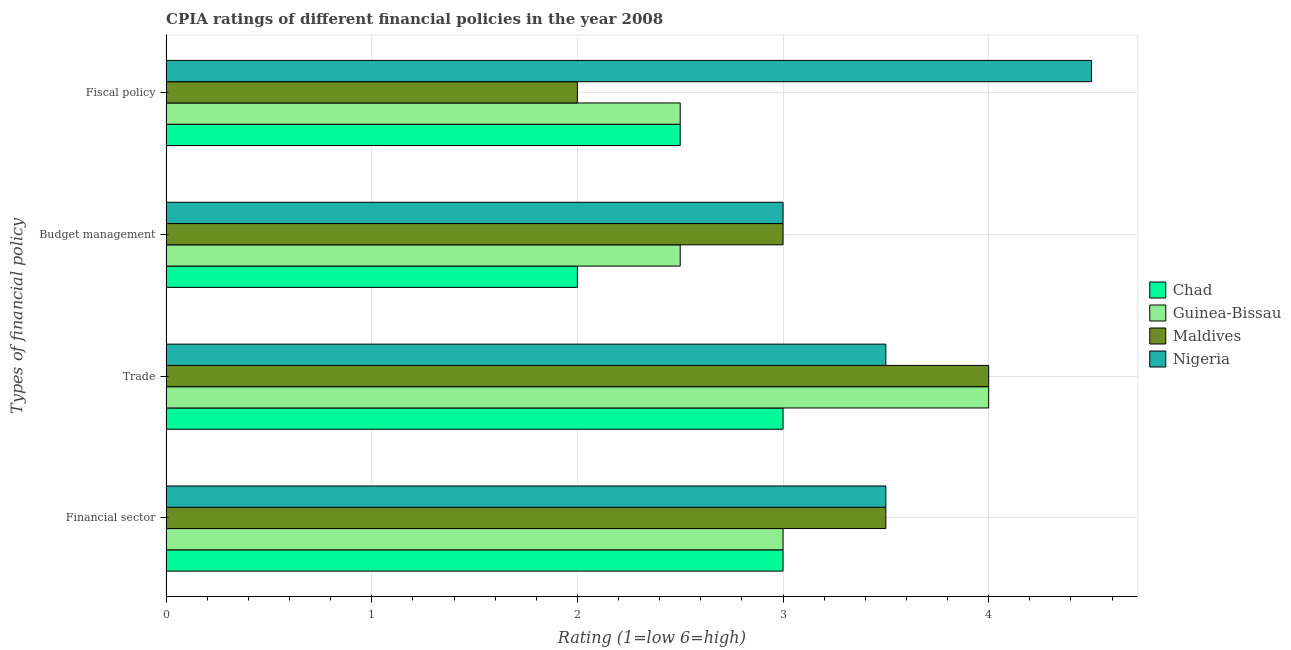How many different coloured bars are there?
Ensure brevity in your answer.  4. Are the number of bars on each tick of the Y-axis equal?
Offer a terse response. Yes. How many bars are there on the 3rd tick from the top?
Give a very brief answer. 4. How many bars are there on the 2nd tick from the bottom?
Your answer should be compact. 4. What is the label of the 3rd group of bars from the top?
Make the answer very short. Trade. Across all countries, what is the maximum cpia rating of budget management?
Offer a terse response. 3. Across all countries, what is the minimum cpia rating of trade?
Provide a short and direct response. 3. In which country was the cpia rating of budget management maximum?
Keep it short and to the point. Maldives. In which country was the cpia rating of fiscal policy minimum?
Give a very brief answer. Maldives. What is the total cpia rating of financial sector in the graph?
Your answer should be very brief. 13. What is the difference between the cpia rating of trade in Maldives and that in Nigeria?
Ensure brevity in your answer.  0.5. What is the average cpia rating of financial sector per country?
Ensure brevity in your answer.  3.25. What is the difference between the cpia rating of budget management and cpia rating of financial sector in Guinea-Bissau?
Give a very brief answer. -0.5. What is the ratio of the cpia rating of fiscal policy in Guinea-Bissau to that in Nigeria?
Your answer should be compact. 0.56. Is the difference between the cpia rating of fiscal policy in Guinea-Bissau and Chad greater than the difference between the cpia rating of trade in Guinea-Bissau and Chad?
Make the answer very short. No. What is the difference between the highest and the second highest cpia rating of budget management?
Ensure brevity in your answer.  0. Is it the case that in every country, the sum of the cpia rating of fiscal policy and cpia rating of budget management is greater than the sum of cpia rating of trade and cpia rating of financial sector?
Your response must be concise. No. What does the 2nd bar from the top in Trade represents?
Your response must be concise. Maldives. What does the 4th bar from the bottom in Financial sector represents?
Offer a very short reply. Nigeria. Is it the case that in every country, the sum of the cpia rating of financial sector and cpia rating of trade is greater than the cpia rating of budget management?
Ensure brevity in your answer.  Yes. How many countries are there in the graph?
Your response must be concise. 4. Does the graph contain any zero values?
Offer a very short reply. No. Where does the legend appear in the graph?
Offer a terse response. Center right. How are the legend labels stacked?
Your response must be concise. Vertical. What is the title of the graph?
Your answer should be compact. CPIA ratings of different financial policies in the year 2008. Does "Somalia" appear as one of the legend labels in the graph?
Provide a short and direct response. No. What is the label or title of the Y-axis?
Make the answer very short. Types of financial policy. What is the Rating (1=low 6=high) of Maldives in Financial sector?
Your answer should be compact. 3.5. What is the Rating (1=low 6=high) of Chad in Trade?
Your response must be concise. 3. What is the Rating (1=low 6=high) in Guinea-Bissau in Trade?
Make the answer very short. 4. What is the Rating (1=low 6=high) in Nigeria in Trade?
Your answer should be compact. 3.5. What is the Rating (1=low 6=high) in Chad in Budget management?
Provide a succinct answer. 2. What is the Rating (1=low 6=high) of Guinea-Bissau in Budget management?
Provide a succinct answer. 2.5. What is the Rating (1=low 6=high) in Nigeria in Budget management?
Offer a very short reply. 3. What is the Rating (1=low 6=high) of Chad in Fiscal policy?
Offer a terse response. 2.5. What is the Rating (1=low 6=high) of Guinea-Bissau in Fiscal policy?
Your answer should be very brief. 2.5. Across all Types of financial policy, what is the maximum Rating (1=low 6=high) in Nigeria?
Your response must be concise. 4.5. Across all Types of financial policy, what is the minimum Rating (1=low 6=high) of Maldives?
Your answer should be compact. 2. Across all Types of financial policy, what is the minimum Rating (1=low 6=high) in Nigeria?
Your response must be concise. 3. What is the total Rating (1=low 6=high) of Chad in the graph?
Your response must be concise. 10.5. What is the total Rating (1=low 6=high) of Nigeria in the graph?
Provide a short and direct response. 14.5. What is the difference between the Rating (1=low 6=high) of Chad in Financial sector and that in Trade?
Your answer should be very brief. 0. What is the difference between the Rating (1=low 6=high) of Maldives in Financial sector and that in Trade?
Your response must be concise. -0.5. What is the difference between the Rating (1=low 6=high) in Chad in Financial sector and that in Budget management?
Offer a terse response. 1. What is the difference between the Rating (1=low 6=high) of Guinea-Bissau in Financial sector and that in Budget management?
Your answer should be compact. 0.5. What is the difference between the Rating (1=low 6=high) in Nigeria in Financial sector and that in Budget management?
Your answer should be compact. 0.5. What is the difference between the Rating (1=low 6=high) in Guinea-Bissau in Financial sector and that in Fiscal policy?
Provide a succinct answer. 0.5. What is the difference between the Rating (1=low 6=high) in Maldives in Financial sector and that in Fiscal policy?
Your response must be concise. 1.5. What is the difference between the Rating (1=low 6=high) in Nigeria in Financial sector and that in Fiscal policy?
Make the answer very short. -1. What is the difference between the Rating (1=low 6=high) in Maldives in Trade and that in Budget management?
Keep it short and to the point. 1. What is the difference between the Rating (1=low 6=high) of Guinea-Bissau in Trade and that in Fiscal policy?
Make the answer very short. 1.5. What is the difference between the Rating (1=low 6=high) in Nigeria in Budget management and that in Fiscal policy?
Provide a short and direct response. -1.5. What is the difference between the Rating (1=low 6=high) of Chad in Financial sector and the Rating (1=low 6=high) of Guinea-Bissau in Trade?
Give a very brief answer. -1. What is the difference between the Rating (1=low 6=high) in Maldives in Financial sector and the Rating (1=low 6=high) in Nigeria in Trade?
Provide a succinct answer. 0. What is the difference between the Rating (1=low 6=high) in Chad in Financial sector and the Rating (1=low 6=high) in Maldives in Budget management?
Your answer should be very brief. 0. What is the difference between the Rating (1=low 6=high) in Guinea-Bissau in Financial sector and the Rating (1=low 6=high) in Maldives in Budget management?
Provide a succinct answer. 0. What is the difference between the Rating (1=low 6=high) in Chad in Financial sector and the Rating (1=low 6=high) in Guinea-Bissau in Fiscal policy?
Offer a terse response. 0.5. What is the difference between the Rating (1=low 6=high) of Chad in Financial sector and the Rating (1=low 6=high) of Maldives in Fiscal policy?
Offer a terse response. 1. What is the difference between the Rating (1=low 6=high) of Chad in Financial sector and the Rating (1=low 6=high) of Nigeria in Fiscal policy?
Provide a short and direct response. -1.5. What is the difference between the Rating (1=low 6=high) in Guinea-Bissau in Financial sector and the Rating (1=low 6=high) in Maldives in Fiscal policy?
Provide a succinct answer. 1. What is the difference between the Rating (1=low 6=high) of Maldives in Financial sector and the Rating (1=low 6=high) of Nigeria in Fiscal policy?
Give a very brief answer. -1. What is the difference between the Rating (1=low 6=high) in Chad in Trade and the Rating (1=low 6=high) in Guinea-Bissau in Budget management?
Offer a very short reply. 0.5. What is the difference between the Rating (1=low 6=high) in Chad in Trade and the Rating (1=low 6=high) in Nigeria in Budget management?
Provide a succinct answer. 0. What is the difference between the Rating (1=low 6=high) of Maldives in Trade and the Rating (1=low 6=high) of Nigeria in Budget management?
Give a very brief answer. 1. What is the difference between the Rating (1=low 6=high) in Chad in Trade and the Rating (1=low 6=high) in Guinea-Bissau in Fiscal policy?
Your response must be concise. 0.5. What is the difference between the Rating (1=low 6=high) of Chad in Trade and the Rating (1=low 6=high) of Maldives in Fiscal policy?
Provide a succinct answer. 1. What is the difference between the Rating (1=low 6=high) in Chad in Trade and the Rating (1=low 6=high) in Nigeria in Fiscal policy?
Provide a short and direct response. -1.5. What is the difference between the Rating (1=low 6=high) of Guinea-Bissau in Trade and the Rating (1=low 6=high) of Maldives in Fiscal policy?
Give a very brief answer. 2. What is the difference between the Rating (1=low 6=high) of Chad in Budget management and the Rating (1=low 6=high) of Guinea-Bissau in Fiscal policy?
Offer a very short reply. -0.5. What is the difference between the Rating (1=low 6=high) in Chad in Budget management and the Rating (1=low 6=high) in Nigeria in Fiscal policy?
Give a very brief answer. -2.5. What is the difference between the Rating (1=low 6=high) in Guinea-Bissau in Budget management and the Rating (1=low 6=high) in Maldives in Fiscal policy?
Give a very brief answer. 0.5. What is the difference between the Rating (1=low 6=high) in Guinea-Bissau in Budget management and the Rating (1=low 6=high) in Nigeria in Fiscal policy?
Give a very brief answer. -2. What is the average Rating (1=low 6=high) in Chad per Types of financial policy?
Provide a short and direct response. 2.62. What is the average Rating (1=low 6=high) of Guinea-Bissau per Types of financial policy?
Your answer should be very brief. 3. What is the average Rating (1=low 6=high) of Maldives per Types of financial policy?
Offer a terse response. 3.12. What is the average Rating (1=low 6=high) of Nigeria per Types of financial policy?
Offer a very short reply. 3.62. What is the difference between the Rating (1=low 6=high) of Chad and Rating (1=low 6=high) of Guinea-Bissau in Financial sector?
Your answer should be very brief. 0. What is the difference between the Rating (1=low 6=high) in Chad and Rating (1=low 6=high) in Nigeria in Financial sector?
Ensure brevity in your answer.  -0.5. What is the difference between the Rating (1=low 6=high) in Guinea-Bissau and Rating (1=low 6=high) in Nigeria in Financial sector?
Provide a short and direct response. -0.5. What is the difference between the Rating (1=low 6=high) in Chad and Rating (1=low 6=high) in Guinea-Bissau in Trade?
Give a very brief answer. -1. What is the difference between the Rating (1=low 6=high) of Guinea-Bissau and Rating (1=low 6=high) of Maldives in Trade?
Give a very brief answer. 0. What is the difference between the Rating (1=low 6=high) of Guinea-Bissau and Rating (1=low 6=high) of Nigeria in Trade?
Give a very brief answer. 0.5. What is the difference between the Rating (1=low 6=high) in Maldives and Rating (1=low 6=high) in Nigeria in Trade?
Your answer should be very brief. 0.5. What is the difference between the Rating (1=low 6=high) in Chad and Rating (1=low 6=high) in Maldives in Budget management?
Your answer should be compact. -1. What is the difference between the Rating (1=low 6=high) of Guinea-Bissau and Rating (1=low 6=high) of Maldives in Budget management?
Keep it short and to the point. -0.5. What is the difference between the Rating (1=low 6=high) of Guinea-Bissau and Rating (1=low 6=high) of Nigeria in Budget management?
Provide a succinct answer. -0.5. What is the difference between the Rating (1=low 6=high) in Maldives and Rating (1=low 6=high) in Nigeria in Budget management?
Your response must be concise. 0. What is the difference between the Rating (1=low 6=high) of Chad and Rating (1=low 6=high) of Maldives in Fiscal policy?
Keep it short and to the point. 0.5. What is the difference between the Rating (1=low 6=high) in Guinea-Bissau and Rating (1=low 6=high) in Maldives in Fiscal policy?
Offer a very short reply. 0.5. What is the difference between the Rating (1=low 6=high) of Guinea-Bissau and Rating (1=low 6=high) of Nigeria in Fiscal policy?
Provide a short and direct response. -2. What is the difference between the Rating (1=low 6=high) of Maldives and Rating (1=low 6=high) of Nigeria in Fiscal policy?
Ensure brevity in your answer.  -2.5. What is the ratio of the Rating (1=low 6=high) in Maldives in Financial sector to that in Trade?
Your answer should be compact. 0.88. What is the ratio of the Rating (1=low 6=high) of Chad in Financial sector to that in Budget management?
Give a very brief answer. 1.5. What is the ratio of the Rating (1=low 6=high) of Nigeria in Financial sector to that in Budget management?
Make the answer very short. 1.17. What is the ratio of the Rating (1=low 6=high) in Guinea-Bissau in Financial sector to that in Fiscal policy?
Provide a short and direct response. 1.2. What is the ratio of the Rating (1=low 6=high) in Chad in Trade to that in Budget management?
Provide a short and direct response. 1.5. What is the ratio of the Rating (1=low 6=high) of Guinea-Bissau in Trade to that in Budget management?
Give a very brief answer. 1.6. What is the ratio of the Rating (1=low 6=high) of Nigeria in Trade to that in Budget management?
Your response must be concise. 1.17. What is the ratio of the Rating (1=low 6=high) of Chad in Budget management to that in Fiscal policy?
Make the answer very short. 0.8. What is the ratio of the Rating (1=low 6=high) in Guinea-Bissau in Budget management to that in Fiscal policy?
Your answer should be very brief. 1. What is the ratio of the Rating (1=low 6=high) in Nigeria in Budget management to that in Fiscal policy?
Your answer should be very brief. 0.67. What is the difference between the highest and the second highest Rating (1=low 6=high) in Guinea-Bissau?
Make the answer very short. 1. What is the difference between the highest and the second highest Rating (1=low 6=high) of Nigeria?
Give a very brief answer. 1. What is the difference between the highest and the lowest Rating (1=low 6=high) in Chad?
Your answer should be very brief. 1. What is the difference between the highest and the lowest Rating (1=low 6=high) of Guinea-Bissau?
Your answer should be compact. 1.5. What is the difference between the highest and the lowest Rating (1=low 6=high) in Nigeria?
Ensure brevity in your answer.  1.5. 